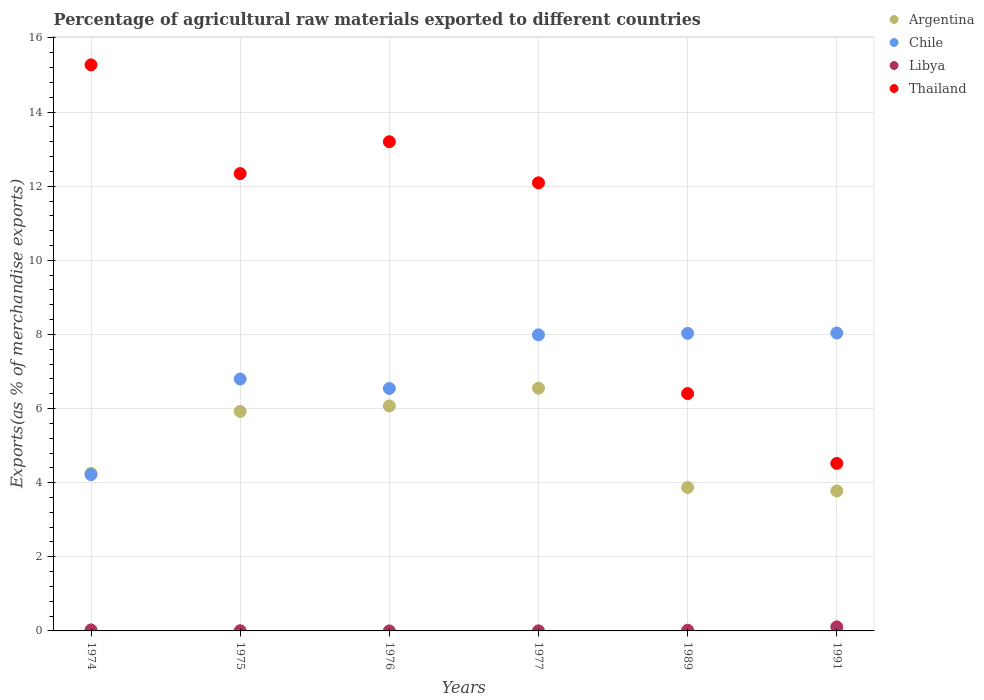What is the percentage of exports to different countries in Libya in 1976?
Provide a succinct answer. 0. Across all years, what is the maximum percentage of exports to different countries in Thailand?
Ensure brevity in your answer.  15.27. Across all years, what is the minimum percentage of exports to different countries in Libya?
Ensure brevity in your answer.  0. What is the total percentage of exports to different countries in Libya in the graph?
Keep it short and to the point. 0.16. What is the difference between the percentage of exports to different countries in Argentina in 1974 and that in 1976?
Make the answer very short. -1.82. What is the difference between the percentage of exports to different countries in Thailand in 1989 and the percentage of exports to different countries in Libya in 1976?
Your answer should be very brief. 6.4. What is the average percentage of exports to different countries in Argentina per year?
Ensure brevity in your answer.  5.07. In the year 1989, what is the difference between the percentage of exports to different countries in Chile and percentage of exports to different countries in Thailand?
Your answer should be compact. 1.62. What is the ratio of the percentage of exports to different countries in Libya in 1977 to that in 1991?
Your response must be concise. 0.02. What is the difference between the highest and the second highest percentage of exports to different countries in Thailand?
Keep it short and to the point. 2.07. What is the difference between the highest and the lowest percentage of exports to different countries in Chile?
Offer a very short reply. 3.82. In how many years, is the percentage of exports to different countries in Thailand greater than the average percentage of exports to different countries in Thailand taken over all years?
Provide a succinct answer. 4. Is it the case that in every year, the sum of the percentage of exports to different countries in Argentina and percentage of exports to different countries in Thailand  is greater than the sum of percentage of exports to different countries in Chile and percentage of exports to different countries in Libya?
Your response must be concise. No. Does the percentage of exports to different countries in Argentina monotonically increase over the years?
Ensure brevity in your answer.  No. Is the percentage of exports to different countries in Libya strictly greater than the percentage of exports to different countries in Argentina over the years?
Ensure brevity in your answer.  No. Is the percentage of exports to different countries in Chile strictly less than the percentage of exports to different countries in Argentina over the years?
Your response must be concise. No. How many dotlines are there?
Ensure brevity in your answer.  4. How many years are there in the graph?
Give a very brief answer. 6. What is the difference between two consecutive major ticks on the Y-axis?
Offer a very short reply. 2. Are the values on the major ticks of Y-axis written in scientific E-notation?
Give a very brief answer. No. Does the graph contain any zero values?
Your response must be concise. No. Does the graph contain grids?
Keep it short and to the point. Yes. Where does the legend appear in the graph?
Offer a terse response. Top right. How many legend labels are there?
Ensure brevity in your answer.  4. How are the legend labels stacked?
Make the answer very short. Vertical. What is the title of the graph?
Your answer should be very brief. Percentage of agricultural raw materials exported to different countries. What is the label or title of the Y-axis?
Make the answer very short. Exports(as % of merchandise exports). What is the Exports(as % of merchandise exports) in Argentina in 1974?
Your response must be concise. 4.25. What is the Exports(as % of merchandise exports) in Chile in 1974?
Your response must be concise. 4.22. What is the Exports(as % of merchandise exports) in Libya in 1974?
Ensure brevity in your answer.  0.03. What is the Exports(as % of merchandise exports) in Thailand in 1974?
Provide a short and direct response. 15.27. What is the Exports(as % of merchandise exports) of Argentina in 1975?
Give a very brief answer. 5.92. What is the Exports(as % of merchandise exports) in Chile in 1975?
Provide a short and direct response. 6.8. What is the Exports(as % of merchandise exports) of Libya in 1975?
Provide a succinct answer. 0.01. What is the Exports(as % of merchandise exports) of Thailand in 1975?
Provide a succinct answer. 12.34. What is the Exports(as % of merchandise exports) of Argentina in 1976?
Offer a terse response. 6.07. What is the Exports(as % of merchandise exports) in Chile in 1976?
Offer a terse response. 6.54. What is the Exports(as % of merchandise exports) of Libya in 1976?
Make the answer very short. 0. What is the Exports(as % of merchandise exports) of Thailand in 1976?
Ensure brevity in your answer.  13.2. What is the Exports(as % of merchandise exports) in Argentina in 1977?
Give a very brief answer. 6.55. What is the Exports(as % of merchandise exports) in Chile in 1977?
Make the answer very short. 7.99. What is the Exports(as % of merchandise exports) in Libya in 1977?
Offer a very short reply. 0. What is the Exports(as % of merchandise exports) in Thailand in 1977?
Provide a short and direct response. 12.09. What is the Exports(as % of merchandise exports) in Argentina in 1989?
Ensure brevity in your answer.  3.87. What is the Exports(as % of merchandise exports) of Chile in 1989?
Keep it short and to the point. 8.03. What is the Exports(as % of merchandise exports) in Libya in 1989?
Provide a succinct answer. 0.02. What is the Exports(as % of merchandise exports) of Thailand in 1989?
Offer a very short reply. 6.4. What is the Exports(as % of merchandise exports) of Argentina in 1991?
Offer a very short reply. 3.78. What is the Exports(as % of merchandise exports) in Chile in 1991?
Give a very brief answer. 8.04. What is the Exports(as % of merchandise exports) of Libya in 1991?
Provide a short and direct response. 0.11. What is the Exports(as % of merchandise exports) in Thailand in 1991?
Provide a succinct answer. 4.52. Across all years, what is the maximum Exports(as % of merchandise exports) in Argentina?
Give a very brief answer. 6.55. Across all years, what is the maximum Exports(as % of merchandise exports) of Chile?
Your answer should be very brief. 8.04. Across all years, what is the maximum Exports(as % of merchandise exports) in Libya?
Ensure brevity in your answer.  0.11. Across all years, what is the maximum Exports(as % of merchandise exports) of Thailand?
Your response must be concise. 15.27. Across all years, what is the minimum Exports(as % of merchandise exports) in Argentina?
Your answer should be very brief. 3.78. Across all years, what is the minimum Exports(as % of merchandise exports) of Chile?
Make the answer very short. 4.22. Across all years, what is the minimum Exports(as % of merchandise exports) of Libya?
Your answer should be very brief. 0. Across all years, what is the minimum Exports(as % of merchandise exports) of Thailand?
Provide a succinct answer. 4.52. What is the total Exports(as % of merchandise exports) in Argentina in the graph?
Ensure brevity in your answer.  30.44. What is the total Exports(as % of merchandise exports) of Chile in the graph?
Your answer should be very brief. 41.61. What is the total Exports(as % of merchandise exports) of Libya in the graph?
Provide a short and direct response. 0.16. What is the total Exports(as % of merchandise exports) of Thailand in the graph?
Make the answer very short. 63.83. What is the difference between the Exports(as % of merchandise exports) of Argentina in 1974 and that in 1975?
Provide a short and direct response. -1.67. What is the difference between the Exports(as % of merchandise exports) of Chile in 1974 and that in 1975?
Keep it short and to the point. -2.58. What is the difference between the Exports(as % of merchandise exports) in Libya in 1974 and that in 1975?
Give a very brief answer. 0.02. What is the difference between the Exports(as % of merchandise exports) in Thailand in 1974 and that in 1975?
Make the answer very short. 2.93. What is the difference between the Exports(as % of merchandise exports) of Argentina in 1974 and that in 1976?
Your response must be concise. -1.82. What is the difference between the Exports(as % of merchandise exports) of Chile in 1974 and that in 1976?
Offer a terse response. -2.32. What is the difference between the Exports(as % of merchandise exports) in Libya in 1974 and that in 1976?
Offer a very short reply. 0.03. What is the difference between the Exports(as % of merchandise exports) of Thailand in 1974 and that in 1976?
Keep it short and to the point. 2.07. What is the difference between the Exports(as % of merchandise exports) of Argentina in 1974 and that in 1977?
Ensure brevity in your answer.  -2.3. What is the difference between the Exports(as % of merchandise exports) of Chile in 1974 and that in 1977?
Provide a succinct answer. -3.77. What is the difference between the Exports(as % of merchandise exports) in Libya in 1974 and that in 1977?
Make the answer very short. 0.02. What is the difference between the Exports(as % of merchandise exports) in Thailand in 1974 and that in 1977?
Your response must be concise. 3.18. What is the difference between the Exports(as % of merchandise exports) of Argentina in 1974 and that in 1989?
Keep it short and to the point. 0.38. What is the difference between the Exports(as % of merchandise exports) in Chile in 1974 and that in 1989?
Provide a succinct answer. -3.81. What is the difference between the Exports(as % of merchandise exports) in Libya in 1974 and that in 1989?
Give a very brief answer. 0.01. What is the difference between the Exports(as % of merchandise exports) in Thailand in 1974 and that in 1989?
Make the answer very short. 8.87. What is the difference between the Exports(as % of merchandise exports) in Argentina in 1974 and that in 1991?
Offer a terse response. 0.48. What is the difference between the Exports(as % of merchandise exports) in Chile in 1974 and that in 1991?
Give a very brief answer. -3.82. What is the difference between the Exports(as % of merchandise exports) of Libya in 1974 and that in 1991?
Offer a terse response. -0.08. What is the difference between the Exports(as % of merchandise exports) in Thailand in 1974 and that in 1991?
Offer a terse response. 10.75. What is the difference between the Exports(as % of merchandise exports) of Argentina in 1975 and that in 1976?
Make the answer very short. -0.15. What is the difference between the Exports(as % of merchandise exports) of Chile in 1975 and that in 1976?
Keep it short and to the point. 0.26. What is the difference between the Exports(as % of merchandise exports) in Libya in 1975 and that in 1976?
Give a very brief answer. 0.01. What is the difference between the Exports(as % of merchandise exports) in Thailand in 1975 and that in 1976?
Your answer should be very brief. -0.86. What is the difference between the Exports(as % of merchandise exports) of Argentina in 1975 and that in 1977?
Your answer should be very brief. -0.63. What is the difference between the Exports(as % of merchandise exports) in Chile in 1975 and that in 1977?
Provide a short and direct response. -1.19. What is the difference between the Exports(as % of merchandise exports) of Libya in 1975 and that in 1977?
Your answer should be compact. 0. What is the difference between the Exports(as % of merchandise exports) in Thailand in 1975 and that in 1977?
Give a very brief answer. 0.25. What is the difference between the Exports(as % of merchandise exports) in Argentina in 1975 and that in 1989?
Your answer should be very brief. 2.05. What is the difference between the Exports(as % of merchandise exports) of Chile in 1975 and that in 1989?
Provide a succinct answer. -1.23. What is the difference between the Exports(as % of merchandise exports) of Libya in 1975 and that in 1989?
Ensure brevity in your answer.  -0.01. What is the difference between the Exports(as % of merchandise exports) of Thailand in 1975 and that in 1989?
Keep it short and to the point. 5.94. What is the difference between the Exports(as % of merchandise exports) in Argentina in 1975 and that in 1991?
Your answer should be compact. 2.15. What is the difference between the Exports(as % of merchandise exports) in Chile in 1975 and that in 1991?
Give a very brief answer. -1.24. What is the difference between the Exports(as % of merchandise exports) in Libya in 1975 and that in 1991?
Ensure brevity in your answer.  -0.1. What is the difference between the Exports(as % of merchandise exports) of Thailand in 1975 and that in 1991?
Keep it short and to the point. 7.82. What is the difference between the Exports(as % of merchandise exports) in Argentina in 1976 and that in 1977?
Ensure brevity in your answer.  -0.48. What is the difference between the Exports(as % of merchandise exports) in Chile in 1976 and that in 1977?
Give a very brief answer. -1.45. What is the difference between the Exports(as % of merchandise exports) of Libya in 1976 and that in 1977?
Provide a short and direct response. -0. What is the difference between the Exports(as % of merchandise exports) in Thailand in 1976 and that in 1977?
Your answer should be compact. 1.11. What is the difference between the Exports(as % of merchandise exports) in Argentina in 1976 and that in 1989?
Give a very brief answer. 2.2. What is the difference between the Exports(as % of merchandise exports) of Chile in 1976 and that in 1989?
Provide a short and direct response. -1.49. What is the difference between the Exports(as % of merchandise exports) in Libya in 1976 and that in 1989?
Offer a very short reply. -0.02. What is the difference between the Exports(as % of merchandise exports) in Thailand in 1976 and that in 1989?
Your response must be concise. 6.8. What is the difference between the Exports(as % of merchandise exports) in Argentina in 1976 and that in 1991?
Ensure brevity in your answer.  2.29. What is the difference between the Exports(as % of merchandise exports) of Chile in 1976 and that in 1991?
Make the answer very short. -1.5. What is the difference between the Exports(as % of merchandise exports) in Libya in 1976 and that in 1991?
Offer a very short reply. -0.11. What is the difference between the Exports(as % of merchandise exports) of Thailand in 1976 and that in 1991?
Provide a short and direct response. 8.68. What is the difference between the Exports(as % of merchandise exports) in Argentina in 1977 and that in 1989?
Provide a succinct answer. 2.68. What is the difference between the Exports(as % of merchandise exports) of Chile in 1977 and that in 1989?
Ensure brevity in your answer.  -0.04. What is the difference between the Exports(as % of merchandise exports) in Libya in 1977 and that in 1989?
Keep it short and to the point. -0.02. What is the difference between the Exports(as % of merchandise exports) of Thailand in 1977 and that in 1989?
Give a very brief answer. 5.69. What is the difference between the Exports(as % of merchandise exports) of Argentina in 1977 and that in 1991?
Offer a very short reply. 2.77. What is the difference between the Exports(as % of merchandise exports) of Chile in 1977 and that in 1991?
Your response must be concise. -0.05. What is the difference between the Exports(as % of merchandise exports) of Libya in 1977 and that in 1991?
Your response must be concise. -0.11. What is the difference between the Exports(as % of merchandise exports) of Thailand in 1977 and that in 1991?
Ensure brevity in your answer.  7.57. What is the difference between the Exports(as % of merchandise exports) in Argentina in 1989 and that in 1991?
Offer a terse response. 0.09. What is the difference between the Exports(as % of merchandise exports) of Chile in 1989 and that in 1991?
Provide a succinct answer. -0.01. What is the difference between the Exports(as % of merchandise exports) in Libya in 1989 and that in 1991?
Provide a succinct answer. -0.09. What is the difference between the Exports(as % of merchandise exports) in Thailand in 1989 and that in 1991?
Give a very brief answer. 1.89. What is the difference between the Exports(as % of merchandise exports) of Argentina in 1974 and the Exports(as % of merchandise exports) of Chile in 1975?
Offer a terse response. -2.55. What is the difference between the Exports(as % of merchandise exports) of Argentina in 1974 and the Exports(as % of merchandise exports) of Libya in 1975?
Your answer should be compact. 4.25. What is the difference between the Exports(as % of merchandise exports) of Argentina in 1974 and the Exports(as % of merchandise exports) of Thailand in 1975?
Your answer should be very brief. -8.09. What is the difference between the Exports(as % of merchandise exports) in Chile in 1974 and the Exports(as % of merchandise exports) in Libya in 1975?
Give a very brief answer. 4.21. What is the difference between the Exports(as % of merchandise exports) in Chile in 1974 and the Exports(as % of merchandise exports) in Thailand in 1975?
Provide a short and direct response. -8.12. What is the difference between the Exports(as % of merchandise exports) of Libya in 1974 and the Exports(as % of merchandise exports) of Thailand in 1975?
Keep it short and to the point. -12.31. What is the difference between the Exports(as % of merchandise exports) of Argentina in 1974 and the Exports(as % of merchandise exports) of Chile in 1976?
Your response must be concise. -2.29. What is the difference between the Exports(as % of merchandise exports) of Argentina in 1974 and the Exports(as % of merchandise exports) of Libya in 1976?
Your answer should be very brief. 4.25. What is the difference between the Exports(as % of merchandise exports) in Argentina in 1974 and the Exports(as % of merchandise exports) in Thailand in 1976?
Your answer should be very brief. -8.95. What is the difference between the Exports(as % of merchandise exports) of Chile in 1974 and the Exports(as % of merchandise exports) of Libya in 1976?
Your answer should be compact. 4.22. What is the difference between the Exports(as % of merchandise exports) in Chile in 1974 and the Exports(as % of merchandise exports) in Thailand in 1976?
Provide a short and direct response. -8.98. What is the difference between the Exports(as % of merchandise exports) in Libya in 1974 and the Exports(as % of merchandise exports) in Thailand in 1976?
Your answer should be very brief. -13.17. What is the difference between the Exports(as % of merchandise exports) of Argentina in 1974 and the Exports(as % of merchandise exports) of Chile in 1977?
Give a very brief answer. -3.74. What is the difference between the Exports(as % of merchandise exports) in Argentina in 1974 and the Exports(as % of merchandise exports) in Libya in 1977?
Provide a short and direct response. 4.25. What is the difference between the Exports(as % of merchandise exports) in Argentina in 1974 and the Exports(as % of merchandise exports) in Thailand in 1977?
Keep it short and to the point. -7.84. What is the difference between the Exports(as % of merchandise exports) of Chile in 1974 and the Exports(as % of merchandise exports) of Libya in 1977?
Your response must be concise. 4.22. What is the difference between the Exports(as % of merchandise exports) in Chile in 1974 and the Exports(as % of merchandise exports) in Thailand in 1977?
Your answer should be very brief. -7.87. What is the difference between the Exports(as % of merchandise exports) of Libya in 1974 and the Exports(as % of merchandise exports) of Thailand in 1977?
Your answer should be compact. -12.06. What is the difference between the Exports(as % of merchandise exports) of Argentina in 1974 and the Exports(as % of merchandise exports) of Chile in 1989?
Make the answer very short. -3.78. What is the difference between the Exports(as % of merchandise exports) of Argentina in 1974 and the Exports(as % of merchandise exports) of Libya in 1989?
Ensure brevity in your answer.  4.23. What is the difference between the Exports(as % of merchandise exports) in Argentina in 1974 and the Exports(as % of merchandise exports) in Thailand in 1989?
Keep it short and to the point. -2.15. What is the difference between the Exports(as % of merchandise exports) in Chile in 1974 and the Exports(as % of merchandise exports) in Libya in 1989?
Keep it short and to the point. 4.2. What is the difference between the Exports(as % of merchandise exports) in Chile in 1974 and the Exports(as % of merchandise exports) in Thailand in 1989?
Ensure brevity in your answer.  -2.19. What is the difference between the Exports(as % of merchandise exports) in Libya in 1974 and the Exports(as % of merchandise exports) in Thailand in 1989?
Offer a very short reply. -6.38. What is the difference between the Exports(as % of merchandise exports) of Argentina in 1974 and the Exports(as % of merchandise exports) of Chile in 1991?
Ensure brevity in your answer.  -3.79. What is the difference between the Exports(as % of merchandise exports) in Argentina in 1974 and the Exports(as % of merchandise exports) in Libya in 1991?
Offer a terse response. 4.14. What is the difference between the Exports(as % of merchandise exports) in Argentina in 1974 and the Exports(as % of merchandise exports) in Thailand in 1991?
Provide a short and direct response. -0.27. What is the difference between the Exports(as % of merchandise exports) of Chile in 1974 and the Exports(as % of merchandise exports) of Libya in 1991?
Your answer should be very brief. 4.11. What is the difference between the Exports(as % of merchandise exports) of Chile in 1974 and the Exports(as % of merchandise exports) of Thailand in 1991?
Keep it short and to the point. -0.3. What is the difference between the Exports(as % of merchandise exports) in Libya in 1974 and the Exports(as % of merchandise exports) in Thailand in 1991?
Give a very brief answer. -4.49. What is the difference between the Exports(as % of merchandise exports) in Argentina in 1975 and the Exports(as % of merchandise exports) in Chile in 1976?
Keep it short and to the point. -0.62. What is the difference between the Exports(as % of merchandise exports) of Argentina in 1975 and the Exports(as % of merchandise exports) of Libya in 1976?
Offer a terse response. 5.92. What is the difference between the Exports(as % of merchandise exports) of Argentina in 1975 and the Exports(as % of merchandise exports) of Thailand in 1976?
Your answer should be very brief. -7.28. What is the difference between the Exports(as % of merchandise exports) in Chile in 1975 and the Exports(as % of merchandise exports) in Libya in 1976?
Offer a very short reply. 6.8. What is the difference between the Exports(as % of merchandise exports) in Chile in 1975 and the Exports(as % of merchandise exports) in Thailand in 1976?
Ensure brevity in your answer.  -6.4. What is the difference between the Exports(as % of merchandise exports) of Libya in 1975 and the Exports(as % of merchandise exports) of Thailand in 1976?
Your answer should be very brief. -13.19. What is the difference between the Exports(as % of merchandise exports) of Argentina in 1975 and the Exports(as % of merchandise exports) of Chile in 1977?
Make the answer very short. -2.07. What is the difference between the Exports(as % of merchandise exports) of Argentina in 1975 and the Exports(as % of merchandise exports) of Libya in 1977?
Make the answer very short. 5.92. What is the difference between the Exports(as % of merchandise exports) in Argentina in 1975 and the Exports(as % of merchandise exports) in Thailand in 1977?
Your response must be concise. -6.17. What is the difference between the Exports(as % of merchandise exports) in Chile in 1975 and the Exports(as % of merchandise exports) in Libya in 1977?
Keep it short and to the point. 6.8. What is the difference between the Exports(as % of merchandise exports) of Chile in 1975 and the Exports(as % of merchandise exports) of Thailand in 1977?
Your answer should be very brief. -5.29. What is the difference between the Exports(as % of merchandise exports) in Libya in 1975 and the Exports(as % of merchandise exports) in Thailand in 1977?
Your answer should be compact. -12.09. What is the difference between the Exports(as % of merchandise exports) in Argentina in 1975 and the Exports(as % of merchandise exports) in Chile in 1989?
Offer a very short reply. -2.11. What is the difference between the Exports(as % of merchandise exports) in Argentina in 1975 and the Exports(as % of merchandise exports) in Libya in 1989?
Your response must be concise. 5.91. What is the difference between the Exports(as % of merchandise exports) of Argentina in 1975 and the Exports(as % of merchandise exports) of Thailand in 1989?
Offer a terse response. -0.48. What is the difference between the Exports(as % of merchandise exports) of Chile in 1975 and the Exports(as % of merchandise exports) of Libya in 1989?
Your response must be concise. 6.78. What is the difference between the Exports(as % of merchandise exports) in Chile in 1975 and the Exports(as % of merchandise exports) in Thailand in 1989?
Give a very brief answer. 0.39. What is the difference between the Exports(as % of merchandise exports) of Libya in 1975 and the Exports(as % of merchandise exports) of Thailand in 1989?
Your answer should be very brief. -6.4. What is the difference between the Exports(as % of merchandise exports) in Argentina in 1975 and the Exports(as % of merchandise exports) in Chile in 1991?
Provide a succinct answer. -2.11. What is the difference between the Exports(as % of merchandise exports) of Argentina in 1975 and the Exports(as % of merchandise exports) of Libya in 1991?
Your response must be concise. 5.81. What is the difference between the Exports(as % of merchandise exports) in Argentina in 1975 and the Exports(as % of merchandise exports) in Thailand in 1991?
Provide a succinct answer. 1.4. What is the difference between the Exports(as % of merchandise exports) in Chile in 1975 and the Exports(as % of merchandise exports) in Libya in 1991?
Make the answer very short. 6.69. What is the difference between the Exports(as % of merchandise exports) in Chile in 1975 and the Exports(as % of merchandise exports) in Thailand in 1991?
Ensure brevity in your answer.  2.28. What is the difference between the Exports(as % of merchandise exports) of Libya in 1975 and the Exports(as % of merchandise exports) of Thailand in 1991?
Give a very brief answer. -4.51. What is the difference between the Exports(as % of merchandise exports) of Argentina in 1976 and the Exports(as % of merchandise exports) of Chile in 1977?
Your answer should be very brief. -1.92. What is the difference between the Exports(as % of merchandise exports) of Argentina in 1976 and the Exports(as % of merchandise exports) of Libya in 1977?
Your answer should be very brief. 6.07. What is the difference between the Exports(as % of merchandise exports) of Argentina in 1976 and the Exports(as % of merchandise exports) of Thailand in 1977?
Your response must be concise. -6.02. What is the difference between the Exports(as % of merchandise exports) of Chile in 1976 and the Exports(as % of merchandise exports) of Libya in 1977?
Provide a short and direct response. 6.54. What is the difference between the Exports(as % of merchandise exports) in Chile in 1976 and the Exports(as % of merchandise exports) in Thailand in 1977?
Provide a succinct answer. -5.55. What is the difference between the Exports(as % of merchandise exports) of Libya in 1976 and the Exports(as % of merchandise exports) of Thailand in 1977?
Give a very brief answer. -12.09. What is the difference between the Exports(as % of merchandise exports) of Argentina in 1976 and the Exports(as % of merchandise exports) of Chile in 1989?
Provide a short and direct response. -1.96. What is the difference between the Exports(as % of merchandise exports) in Argentina in 1976 and the Exports(as % of merchandise exports) in Libya in 1989?
Your answer should be very brief. 6.05. What is the difference between the Exports(as % of merchandise exports) in Argentina in 1976 and the Exports(as % of merchandise exports) in Thailand in 1989?
Ensure brevity in your answer.  -0.33. What is the difference between the Exports(as % of merchandise exports) in Chile in 1976 and the Exports(as % of merchandise exports) in Libya in 1989?
Provide a short and direct response. 6.52. What is the difference between the Exports(as % of merchandise exports) in Chile in 1976 and the Exports(as % of merchandise exports) in Thailand in 1989?
Keep it short and to the point. 0.14. What is the difference between the Exports(as % of merchandise exports) in Libya in 1976 and the Exports(as % of merchandise exports) in Thailand in 1989?
Provide a short and direct response. -6.4. What is the difference between the Exports(as % of merchandise exports) of Argentina in 1976 and the Exports(as % of merchandise exports) of Chile in 1991?
Provide a succinct answer. -1.97. What is the difference between the Exports(as % of merchandise exports) of Argentina in 1976 and the Exports(as % of merchandise exports) of Libya in 1991?
Keep it short and to the point. 5.96. What is the difference between the Exports(as % of merchandise exports) in Argentina in 1976 and the Exports(as % of merchandise exports) in Thailand in 1991?
Ensure brevity in your answer.  1.55. What is the difference between the Exports(as % of merchandise exports) of Chile in 1976 and the Exports(as % of merchandise exports) of Libya in 1991?
Offer a very short reply. 6.43. What is the difference between the Exports(as % of merchandise exports) of Chile in 1976 and the Exports(as % of merchandise exports) of Thailand in 1991?
Offer a very short reply. 2.02. What is the difference between the Exports(as % of merchandise exports) of Libya in 1976 and the Exports(as % of merchandise exports) of Thailand in 1991?
Offer a very short reply. -4.52. What is the difference between the Exports(as % of merchandise exports) in Argentina in 1977 and the Exports(as % of merchandise exports) in Chile in 1989?
Make the answer very short. -1.48. What is the difference between the Exports(as % of merchandise exports) in Argentina in 1977 and the Exports(as % of merchandise exports) in Libya in 1989?
Your answer should be compact. 6.53. What is the difference between the Exports(as % of merchandise exports) in Argentina in 1977 and the Exports(as % of merchandise exports) in Thailand in 1989?
Offer a terse response. 0.14. What is the difference between the Exports(as % of merchandise exports) of Chile in 1977 and the Exports(as % of merchandise exports) of Libya in 1989?
Give a very brief answer. 7.97. What is the difference between the Exports(as % of merchandise exports) in Chile in 1977 and the Exports(as % of merchandise exports) in Thailand in 1989?
Make the answer very short. 1.58. What is the difference between the Exports(as % of merchandise exports) of Libya in 1977 and the Exports(as % of merchandise exports) of Thailand in 1989?
Make the answer very short. -6.4. What is the difference between the Exports(as % of merchandise exports) in Argentina in 1977 and the Exports(as % of merchandise exports) in Chile in 1991?
Offer a very short reply. -1.49. What is the difference between the Exports(as % of merchandise exports) in Argentina in 1977 and the Exports(as % of merchandise exports) in Libya in 1991?
Ensure brevity in your answer.  6.44. What is the difference between the Exports(as % of merchandise exports) in Argentina in 1977 and the Exports(as % of merchandise exports) in Thailand in 1991?
Your response must be concise. 2.03. What is the difference between the Exports(as % of merchandise exports) in Chile in 1977 and the Exports(as % of merchandise exports) in Libya in 1991?
Ensure brevity in your answer.  7.88. What is the difference between the Exports(as % of merchandise exports) in Chile in 1977 and the Exports(as % of merchandise exports) in Thailand in 1991?
Your answer should be compact. 3.47. What is the difference between the Exports(as % of merchandise exports) in Libya in 1977 and the Exports(as % of merchandise exports) in Thailand in 1991?
Make the answer very short. -4.52. What is the difference between the Exports(as % of merchandise exports) of Argentina in 1989 and the Exports(as % of merchandise exports) of Chile in 1991?
Ensure brevity in your answer.  -4.17. What is the difference between the Exports(as % of merchandise exports) in Argentina in 1989 and the Exports(as % of merchandise exports) in Libya in 1991?
Make the answer very short. 3.76. What is the difference between the Exports(as % of merchandise exports) in Argentina in 1989 and the Exports(as % of merchandise exports) in Thailand in 1991?
Ensure brevity in your answer.  -0.65. What is the difference between the Exports(as % of merchandise exports) in Chile in 1989 and the Exports(as % of merchandise exports) in Libya in 1991?
Offer a terse response. 7.92. What is the difference between the Exports(as % of merchandise exports) of Chile in 1989 and the Exports(as % of merchandise exports) of Thailand in 1991?
Make the answer very short. 3.51. What is the difference between the Exports(as % of merchandise exports) in Libya in 1989 and the Exports(as % of merchandise exports) in Thailand in 1991?
Ensure brevity in your answer.  -4.5. What is the average Exports(as % of merchandise exports) in Argentina per year?
Provide a succinct answer. 5.07. What is the average Exports(as % of merchandise exports) of Chile per year?
Your response must be concise. 6.94. What is the average Exports(as % of merchandise exports) in Libya per year?
Ensure brevity in your answer.  0.03. What is the average Exports(as % of merchandise exports) in Thailand per year?
Make the answer very short. 10.64. In the year 1974, what is the difference between the Exports(as % of merchandise exports) in Argentina and Exports(as % of merchandise exports) in Chile?
Your answer should be compact. 0.03. In the year 1974, what is the difference between the Exports(as % of merchandise exports) in Argentina and Exports(as % of merchandise exports) in Libya?
Provide a short and direct response. 4.23. In the year 1974, what is the difference between the Exports(as % of merchandise exports) in Argentina and Exports(as % of merchandise exports) in Thailand?
Provide a succinct answer. -11.02. In the year 1974, what is the difference between the Exports(as % of merchandise exports) in Chile and Exports(as % of merchandise exports) in Libya?
Offer a terse response. 4.19. In the year 1974, what is the difference between the Exports(as % of merchandise exports) of Chile and Exports(as % of merchandise exports) of Thailand?
Your answer should be very brief. -11.06. In the year 1974, what is the difference between the Exports(as % of merchandise exports) of Libya and Exports(as % of merchandise exports) of Thailand?
Offer a very short reply. -15.25. In the year 1975, what is the difference between the Exports(as % of merchandise exports) of Argentina and Exports(as % of merchandise exports) of Chile?
Make the answer very short. -0.87. In the year 1975, what is the difference between the Exports(as % of merchandise exports) in Argentina and Exports(as % of merchandise exports) in Libya?
Keep it short and to the point. 5.92. In the year 1975, what is the difference between the Exports(as % of merchandise exports) of Argentina and Exports(as % of merchandise exports) of Thailand?
Ensure brevity in your answer.  -6.42. In the year 1975, what is the difference between the Exports(as % of merchandise exports) in Chile and Exports(as % of merchandise exports) in Libya?
Offer a very short reply. 6.79. In the year 1975, what is the difference between the Exports(as % of merchandise exports) in Chile and Exports(as % of merchandise exports) in Thailand?
Make the answer very short. -5.54. In the year 1975, what is the difference between the Exports(as % of merchandise exports) of Libya and Exports(as % of merchandise exports) of Thailand?
Make the answer very short. -12.34. In the year 1976, what is the difference between the Exports(as % of merchandise exports) in Argentina and Exports(as % of merchandise exports) in Chile?
Provide a succinct answer. -0.47. In the year 1976, what is the difference between the Exports(as % of merchandise exports) in Argentina and Exports(as % of merchandise exports) in Libya?
Provide a short and direct response. 6.07. In the year 1976, what is the difference between the Exports(as % of merchandise exports) of Argentina and Exports(as % of merchandise exports) of Thailand?
Keep it short and to the point. -7.13. In the year 1976, what is the difference between the Exports(as % of merchandise exports) in Chile and Exports(as % of merchandise exports) in Libya?
Offer a terse response. 6.54. In the year 1976, what is the difference between the Exports(as % of merchandise exports) of Chile and Exports(as % of merchandise exports) of Thailand?
Offer a very short reply. -6.66. In the year 1976, what is the difference between the Exports(as % of merchandise exports) in Libya and Exports(as % of merchandise exports) in Thailand?
Your answer should be very brief. -13.2. In the year 1977, what is the difference between the Exports(as % of merchandise exports) in Argentina and Exports(as % of merchandise exports) in Chile?
Keep it short and to the point. -1.44. In the year 1977, what is the difference between the Exports(as % of merchandise exports) in Argentina and Exports(as % of merchandise exports) in Libya?
Your answer should be very brief. 6.55. In the year 1977, what is the difference between the Exports(as % of merchandise exports) of Argentina and Exports(as % of merchandise exports) of Thailand?
Your answer should be very brief. -5.54. In the year 1977, what is the difference between the Exports(as % of merchandise exports) of Chile and Exports(as % of merchandise exports) of Libya?
Offer a very short reply. 7.99. In the year 1977, what is the difference between the Exports(as % of merchandise exports) in Chile and Exports(as % of merchandise exports) in Thailand?
Provide a short and direct response. -4.1. In the year 1977, what is the difference between the Exports(as % of merchandise exports) in Libya and Exports(as % of merchandise exports) in Thailand?
Give a very brief answer. -12.09. In the year 1989, what is the difference between the Exports(as % of merchandise exports) in Argentina and Exports(as % of merchandise exports) in Chile?
Your answer should be very brief. -4.16. In the year 1989, what is the difference between the Exports(as % of merchandise exports) of Argentina and Exports(as % of merchandise exports) of Libya?
Give a very brief answer. 3.85. In the year 1989, what is the difference between the Exports(as % of merchandise exports) of Argentina and Exports(as % of merchandise exports) of Thailand?
Make the answer very short. -2.53. In the year 1989, what is the difference between the Exports(as % of merchandise exports) in Chile and Exports(as % of merchandise exports) in Libya?
Your answer should be very brief. 8.01. In the year 1989, what is the difference between the Exports(as % of merchandise exports) in Chile and Exports(as % of merchandise exports) in Thailand?
Offer a terse response. 1.62. In the year 1989, what is the difference between the Exports(as % of merchandise exports) of Libya and Exports(as % of merchandise exports) of Thailand?
Offer a terse response. -6.39. In the year 1991, what is the difference between the Exports(as % of merchandise exports) of Argentina and Exports(as % of merchandise exports) of Chile?
Ensure brevity in your answer.  -4.26. In the year 1991, what is the difference between the Exports(as % of merchandise exports) in Argentina and Exports(as % of merchandise exports) in Libya?
Offer a very short reply. 3.67. In the year 1991, what is the difference between the Exports(as % of merchandise exports) of Argentina and Exports(as % of merchandise exports) of Thailand?
Your answer should be compact. -0.74. In the year 1991, what is the difference between the Exports(as % of merchandise exports) of Chile and Exports(as % of merchandise exports) of Libya?
Provide a succinct answer. 7.93. In the year 1991, what is the difference between the Exports(as % of merchandise exports) in Chile and Exports(as % of merchandise exports) in Thailand?
Offer a very short reply. 3.52. In the year 1991, what is the difference between the Exports(as % of merchandise exports) in Libya and Exports(as % of merchandise exports) in Thailand?
Make the answer very short. -4.41. What is the ratio of the Exports(as % of merchandise exports) of Argentina in 1974 to that in 1975?
Your answer should be compact. 0.72. What is the ratio of the Exports(as % of merchandise exports) of Chile in 1974 to that in 1975?
Your answer should be very brief. 0.62. What is the ratio of the Exports(as % of merchandise exports) of Libya in 1974 to that in 1975?
Your response must be concise. 4.74. What is the ratio of the Exports(as % of merchandise exports) of Thailand in 1974 to that in 1975?
Your answer should be compact. 1.24. What is the ratio of the Exports(as % of merchandise exports) in Argentina in 1974 to that in 1976?
Your response must be concise. 0.7. What is the ratio of the Exports(as % of merchandise exports) of Chile in 1974 to that in 1976?
Provide a short and direct response. 0.64. What is the ratio of the Exports(as % of merchandise exports) in Libya in 1974 to that in 1976?
Your answer should be compact. 179.67. What is the ratio of the Exports(as % of merchandise exports) of Thailand in 1974 to that in 1976?
Your response must be concise. 1.16. What is the ratio of the Exports(as % of merchandise exports) in Argentina in 1974 to that in 1977?
Provide a short and direct response. 0.65. What is the ratio of the Exports(as % of merchandise exports) of Chile in 1974 to that in 1977?
Ensure brevity in your answer.  0.53. What is the ratio of the Exports(as % of merchandise exports) in Libya in 1974 to that in 1977?
Provide a short and direct response. 12.25. What is the ratio of the Exports(as % of merchandise exports) of Thailand in 1974 to that in 1977?
Give a very brief answer. 1.26. What is the ratio of the Exports(as % of merchandise exports) in Argentina in 1974 to that in 1989?
Give a very brief answer. 1.1. What is the ratio of the Exports(as % of merchandise exports) of Chile in 1974 to that in 1989?
Keep it short and to the point. 0.53. What is the ratio of the Exports(as % of merchandise exports) of Libya in 1974 to that in 1989?
Your answer should be compact. 1.46. What is the ratio of the Exports(as % of merchandise exports) in Thailand in 1974 to that in 1989?
Keep it short and to the point. 2.38. What is the ratio of the Exports(as % of merchandise exports) in Argentina in 1974 to that in 1991?
Make the answer very short. 1.13. What is the ratio of the Exports(as % of merchandise exports) in Chile in 1974 to that in 1991?
Your answer should be compact. 0.52. What is the ratio of the Exports(as % of merchandise exports) in Libya in 1974 to that in 1991?
Offer a terse response. 0.25. What is the ratio of the Exports(as % of merchandise exports) in Thailand in 1974 to that in 1991?
Offer a very short reply. 3.38. What is the ratio of the Exports(as % of merchandise exports) in Argentina in 1975 to that in 1976?
Provide a short and direct response. 0.98. What is the ratio of the Exports(as % of merchandise exports) of Chile in 1975 to that in 1976?
Give a very brief answer. 1.04. What is the ratio of the Exports(as % of merchandise exports) of Libya in 1975 to that in 1976?
Make the answer very short. 37.93. What is the ratio of the Exports(as % of merchandise exports) of Thailand in 1975 to that in 1976?
Provide a short and direct response. 0.93. What is the ratio of the Exports(as % of merchandise exports) of Argentina in 1975 to that in 1977?
Your answer should be very brief. 0.9. What is the ratio of the Exports(as % of merchandise exports) of Chile in 1975 to that in 1977?
Make the answer very short. 0.85. What is the ratio of the Exports(as % of merchandise exports) in Libya in 1975 to that in 1977?
Provide a short and direct response. 2.59. What is the ratio of the Exports(as % of merchandise exports) in Thailand in 1975 to that in 1977?
Offer a very short reply. 1.02. What is the ratio of the Exports(as % of merchandise exports) of Argentina in 1975 to that in 1989?
Your answer should be very brief. 1.53. What is the ratio of the Exports(as % of merchandise exports) of Chile in 1975 to that in 1989?
Offer a very short reply. 0.85. What is the ratio of the Exports(as % of merchandise exports) of Libya in 1975 to that in 1989?
Your answer should be very brief. 0.31. What is the ratio of the Exports(as % of merchandise exports) of Thailand in 1975 to that in 1989?
Make the answer very short. 1.93. What is the ratio of the Exports(as % of merchandise exports) in Argentina in 1975 to that in 1991?
Provide a short and direct response. 1.57. What is the ratio of the Exports(as % of merchandise exports) of Chile in 1975 to that in 1991?
Provide a succinct answer. 0.85. What is the ratio of the Exports(as % of merchandise exports) of Libya in 1975 to that in 1991?
Ensure brevity in your answer.  0.05. What is the ratio of the Exports(as % of merchandise exports) of Thailand in 1975 to that in 1991?
Make the answer very short. 2.73. What is the ratio of the Exports(as % of merchandise exports) in Argentina in 1976 to that in 1977?
Provide a short and direct response. 0.93. What is the ratio of the Exports(as % of merchandise exports) of Chile in 1976 to that in 1977?
Ensure brevity in your answer.  0.82. What is the ratio of the Exports(as % of merchandise exports) of Libya in 1976 to that in 1977?
Provide a succinct answer. 0.07. What is the ratio of the Exports(as % of merchandise exports) in Thailand in 1976 to that in 1977?
Make the answer very short. 1.09. What is the ratio of the Exports(as % of merchandise exports) of Argentina in 1976 to that in 1989?
Your answer should be compact. 1.57. What is the ratio of the Exports(as % of merchandise exports) of Chile in 1976 to that in 1989?
Ensure brevity in your answer.  0.81. What is the ratio of the Exports(as % of merchandise exports) in Libya in 1976 to that in 1989?
Your answer should be compact. 0.01. What is the ratio of the Exports(as % of merchandise exports) of Thailand in 1976 to that in 1989?
Your answer should be compact. 2.06. What is the ratio of the Exports(as % of merchandise exports) in Argentina in 1976 to that in 1991?
Make the answer very short. 1.61. What is the ratio of the Exports(as % of merchandise exports) of Chile in 1976 to that in 1991?
Your answer should be compact. 0.81. What is the ratio of the Exports(as % of merchandise exports) in Libya in 1976 to that in 1991?
Your response must be concise. 0. What is the ratio of the Exports(as % of merchandise exports) of Thailand in 1976 to that in 1991?
Your response must be concise. 2.92. What is the ratio of the Exports(as % of merchandise exports) of Argentina in 1977 to that in 1989?
Offer a very short reply. 1.69. What is the ratio of the Exports(as % of merchandise exports) of Libya in 1977 to that in 1989?
Offer a very short reply. 0.12. What is the ratio of the Exports(as % of merchandise exports) of Thailand in 1977 to that in 1989?
Ensure brevity in your answer.  1.89. What is the ratio of the Exports(as % of merchandise exports) of Argentina in 1977 to that in 1991?
Offer a very short reply. 1.73. What is the ratio of the Exports(as % of merchandise exports) in Libya in 1977 to that in 1991?
Offer a very short reply. 0.02. What is the ratio of the Exports(as % of merchandise exports) in Thailand in 1977 to that in 1991?
Your response must be concise. 2.68. What is the ratio of the Exports(as % of merchandise exports) of Argentina in 1989 to that in 1991?
Keep it short and to the point. 1.02. What is the ratio of the Exports(as % of merchandise exports) in Libya in 1989 to that in 1991?
Keep it short and to the point. 0.17. What is the ratio of the Exports(as % of merchandise exports) of Thailand in 1989 to that in 1991?
Make the answer very short. 1.42. What is the difference between the highest and the second highest Exports(as % of merchandise exports) in Argentina?
Make the answer very short. 0.48. What is the difference between the highest and the second highest Exports(as % of merchandise exports) in Chile?
Offer a terse response. 0.01. What is the difference between the highest and the second highest Exports(as % of merchandise exports) in Libya?
Make the answer very short. 0.08. What is the difference between the highest and the second highest Exports(as % of merchandise exports) of Thailand?
Your answer should be very brief. 2.07. What is the difference between the highest and the lowest Exports(as % of merchandise exports) of Argentina?
Provide a succinct answer. 2.77. What is the difference between the highest and the lowest Exports(as % of merchandise exports) of Chile?
Make the answer very short. 3.82. What is the difference between the highest and the lowest Exports(as % of merchandise exports) in Libya?
Offer a very short reply. 0.11. What is the difference between the highest and the lowest Exports(as % of merchandise exports) in Thailand?
Offer a very short reply. 10.75. 